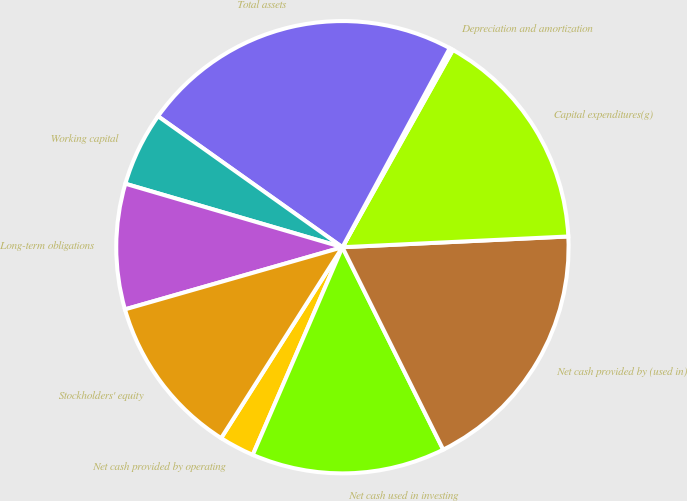Convert chart. <chart><loc_0><loc_0><loc_500><loc_500><pie_chart><fcel>Net cash provided by operating<fcel>Net cash used in investing<fcel>Net cash provided by (used in)<fcel>Capital expenditures(g)<fcel>Depreciation and amortization<fcel>Total assets<fcel>Working capital<fcel>Long-term obligations<fcel>Stockholders' equity<nl><fcel>2.52%<fcel>13.84%<fcel>18.4%<fcel>16.12%<fcel>0.25%<fcel>23.04%<fcel>5.3%<fcel>8.96%<fcel>11.56%<nl></chart> 